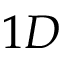<formula> <loc_0><loc_0><loc_500><loc_500>1 D</formula> 